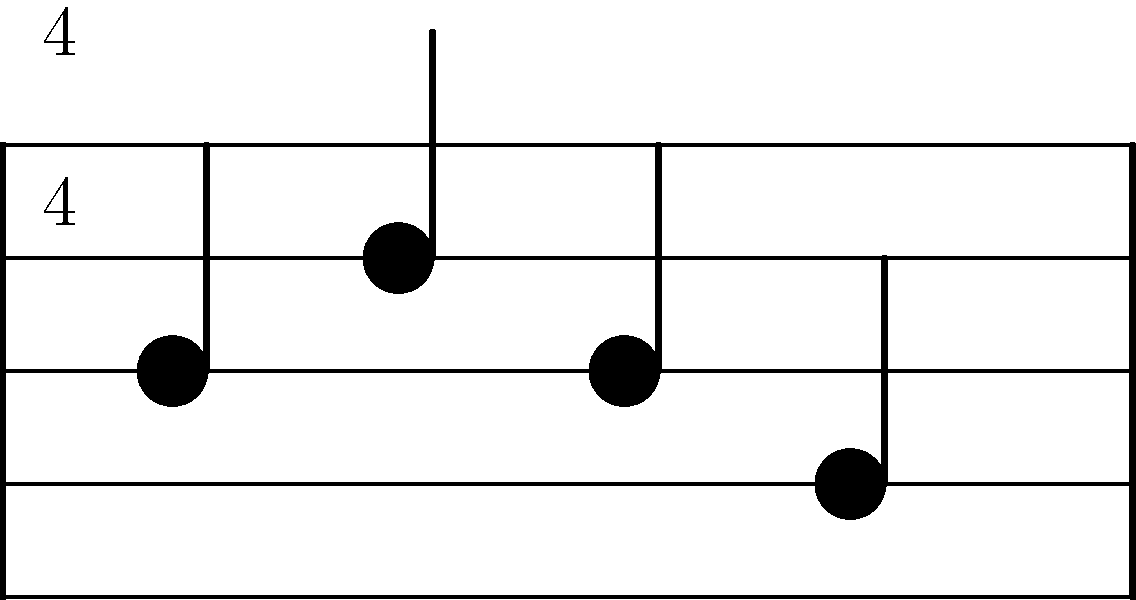As a seasoned music producer from the Pakistani rock scene, you're revisiting some old sheet music. Based on the time signature and note placement in the provided musical staff, what is the time signature of this rock music excerpt? To determine the time signature, let's break it down step-by-step:

1. First, observe the numbers at the beginning of the staff. We can see a "4" over another "4". This is the standard notation for time signature.

2. In time signature notation, the top number represents the number of beats in each measure, while the bottom number represents the note value that gets one beat.

3. In this case, the top "4" indicates that there are four beats in each measure.

4. The bottom "4" tells us that a quarter note gets one beat.

5. This combination of 4/4 is also known as "common time" in music theory and is frequently used in rock music.

6. We can confirm this by looking at the note placement. There are four quarter notes in the measure, each occupying one beat, which aligns with the 4/4 time signature.

7. This time signature was indeed popular during the golden era of Pakistani rock music, as it provides a steady, driving rhythm that's characteristic of many rock songs.
Answer: 4/4 